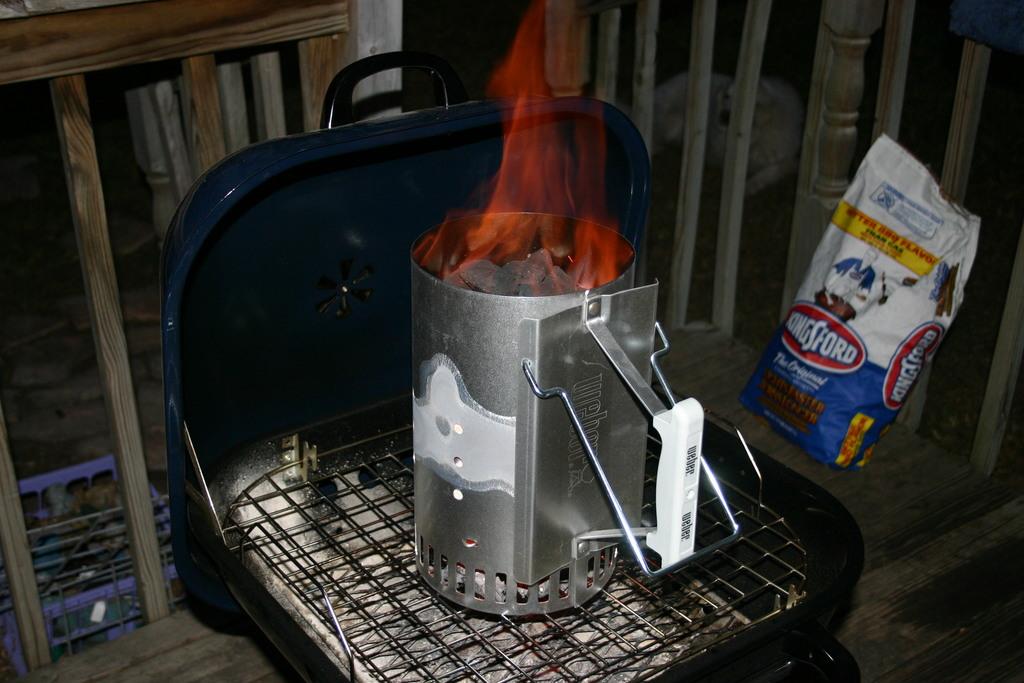What brand of charcoal are they cooking with?
Your answer should be compact. Kingsford. What is the name on the bag?
Your answer should be compact. Kingsford. 